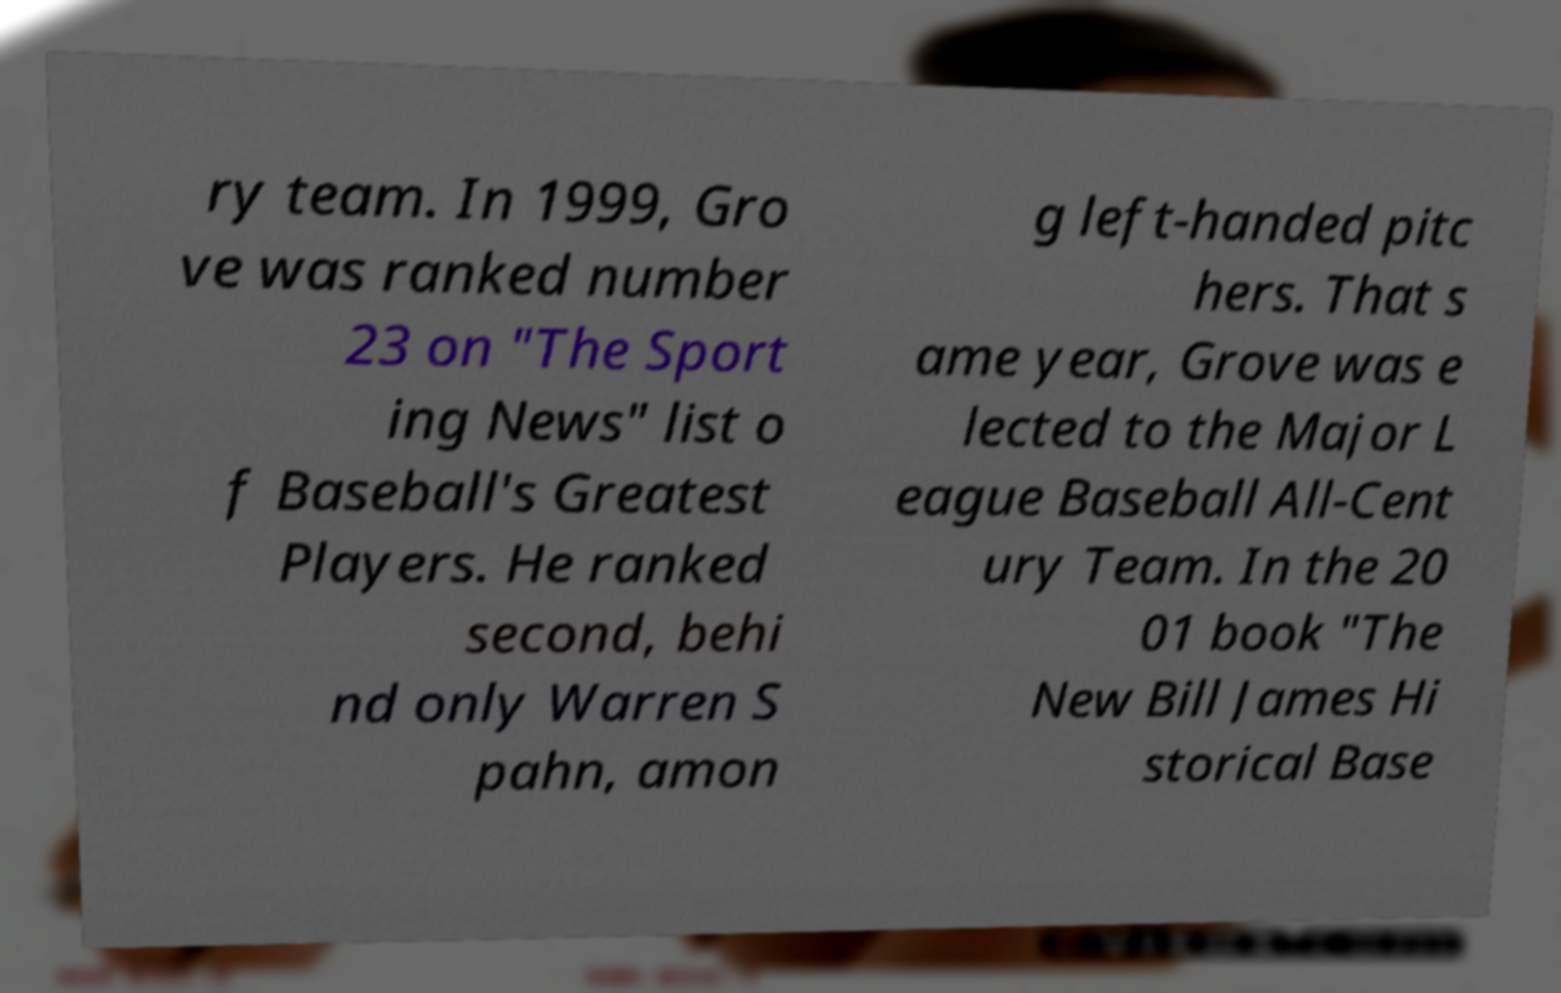I need the written content from this picture converted into text. Can you do that? ry team. In 1999, Gro ve was ranked number 23 on "The Sport ing News" list o f Baseball's Greatest Players. He ranked second, behi nd only Warren S pahn, amon g left-handed pitc hers. That s ame year, Grove was e lected to the Major L eague Baseball All-Cent ury Team. In the 20 01 book "The New Bill James Hi storical Base 